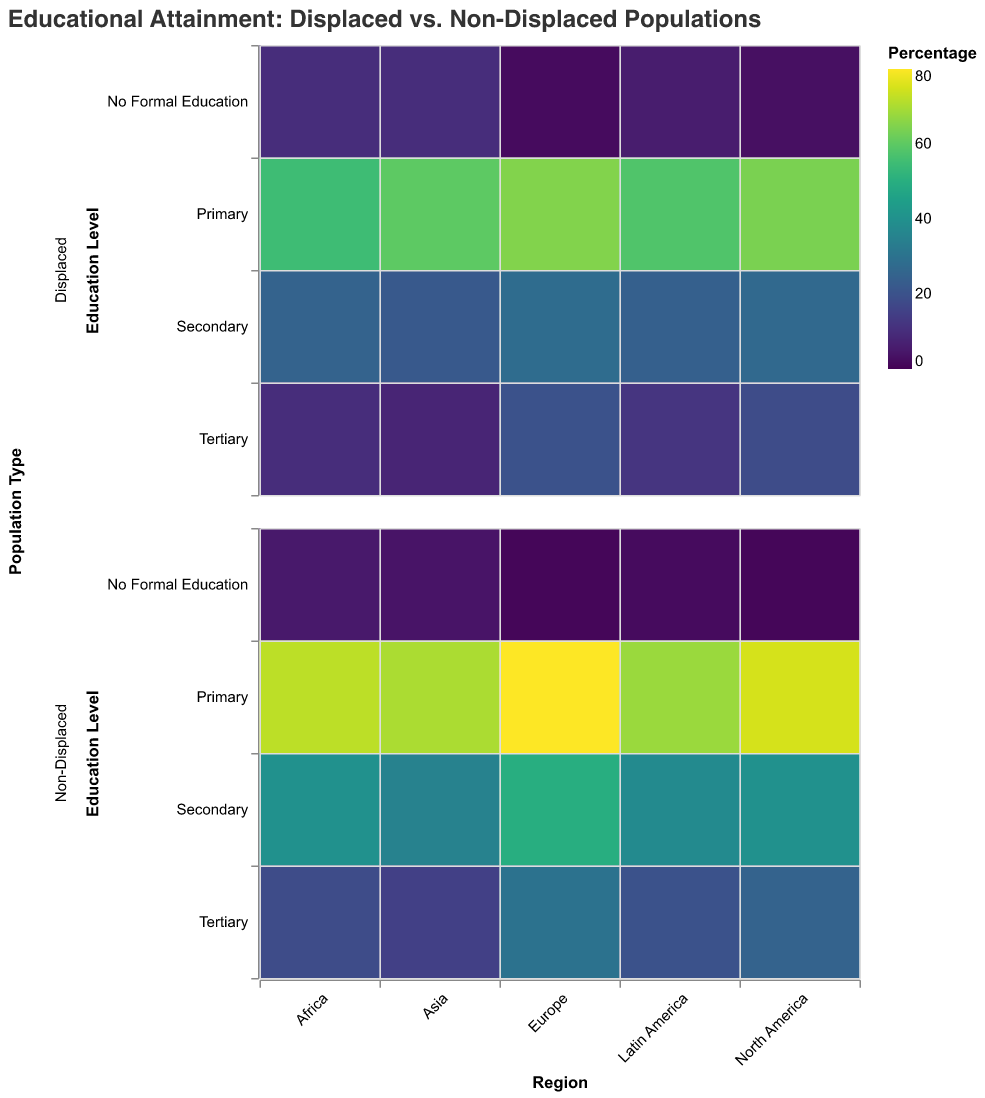Which region has the highest percentage of displaced individuals with no formal education? By examining the heatmap, we see the row for "No Formal Education" in the "Displaced" population. The highest percentage is found in Africa with 10%.
Answer: Africa In which region do non-displaced individuals have the highest percentage of primary education? Look at the row for "Primary" education in the "Non-Displaced" population column. The highest percentage is 80% in Europe.
Answer: Europe What's the difference in tertiary education levels between displaced and non-displaced populations in Latin America? For Latin America, the percentage of tertiary education for the displaced is 12% and for the non-displaced it's 20%. The difference is 20% - 12% = 8%.
Answer: 8% Which educational level shows the smallest difference between displaced and non-displaced populations in North America? In North America, compare the percentages for each educational level:
- Primary: 75 - 64 = 11%
- Secondary: 40 - 27 = 13%
- Tertiary: 25 - 18 = 7%
- No Formal Education: 1 - 3 = -2%
Thus, "No Formal Education" shows the smallest difference as -2%.
Answer: No Formal Education In which region does the displaced population have the highest percentage of tertiary education? Check the row for "Tertiary" education in the "Displaced" population column. The highest percentage is 20% in Europe.
Answer: Europe How does the percentage of secondary education differ between displaced populations in Asia and Europe? For Asia, the percentage is 22%. For Europe, it is 28%. The difference is 28% - 22% = 6%.
Answer: 6% In Africa, what is the ratio of primary education between non-displaced and displaced populations? For Africa, the primary education percentages are 72% (non-displaced) and 55% (displaced). The ratio is 72/55, which simplifies to approximately 1.31.
Answer: 1.31 Do non-displaced populations in Asia have a higher or lower percentage of no formal education compared to displaced populations in the same region? For Asia, non-displaced populations have 4% with no formal education, while displaced populations have 10%. Thus, non-displaced populations have a lower percentage.
Answer: Lower Which education level in Europe shows the highest discrepancy between displaced and non-displaced populations? By checking all education levels in Europe, we find:
- Primary: 80 - 65 = 15
- Secondary: 50 - 28 = 22
- Tertiary: 30 - 20 = 10
- No Formal Education: 1 - 2 = -1
The highest discrepancy is for secondary education with a difference of 22%.
Answer: Secondary For Latin America, what is the combined percentage of primary and secondary education among displaced populations? In Latin America for displaced populations, primary education is 58% and secondary education is 24%. The combined percentage is 58 + 24 = 82%.
Answer: 82% 